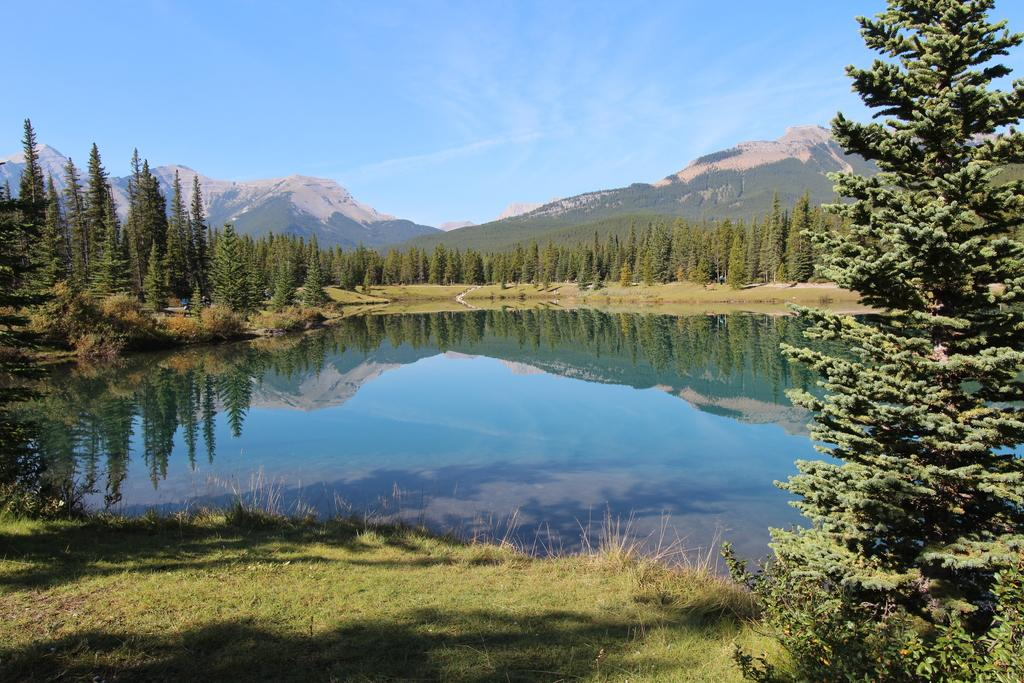What is one of the natural elements present in the image? There is water in the image. What type of vegetation can be seen in the image? There is grass, plants, and trees in the image. What is visible in the background of the image? There is a mountain and the sky in the background of the image. What color are the trousers worn by the mountain in the image? There are no trousers present in the image, as the mountain is a natural formation and not a person wearing clothing. 